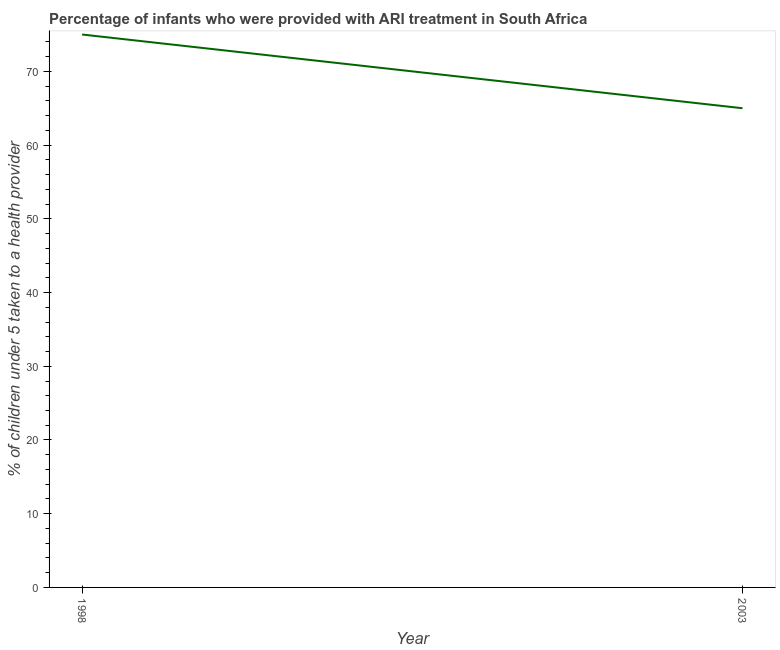What is the percentage of children who were provided with ari treatment in 1998?
Your answer should be compact. 75. Across all years, what is the maximum percentage of children who were provided with ari treatment?
Ensure brevity in your answer.  75. Across all years, what is the minimum percentage of children who were provided with ari treatment?
Give a very brief answer. 65. In which year was the percentage of children who were provided with ari treatment maximum?
Provide a succinct answer. 1998. What is the sum of the percentage of children who were provided with ari treatment?
Ensure brevity in your answer.  140. What is the difference between the percentage of children who were provided with ari treatment in 1998 and 2003?
Give a very brief answer. 10. In how many years, is the percentage of children who were provided with ari treatment greater than 2 %?
Your response must be concise. 2. Do a majority of the years between 1998 and 2003 (inclusive) have percentage of children who were provided with ari treatment greater than 28 %?
Make the answer very short. Yes. What is the ratio of the percentage of children who were provided with ari treatment in 1998 to that in 2003?
Ensure brevity in your answer.  1.15. How many years are there in the graph?
Give a very brief answer. 2. Are the values on the major ticks of Y-axis written in scientific E-notation?
Keep it short and to the point. No. Does the graph contain any zero values?
Offer a terse response. No. Does the graph contain grids?
Give a very brief answer. No. What is the title of the graph?
Your response must be concise. Percentage of infants who were provided with ARI treatment in South Africa. What is the label or title of the X-axis?
Offer a terse response. Year. What is the label or title of the Y-axis?
Your answer should be very brief. % of children under 5 taken to a health provider. What is the % of children under 5 taken to a health provider of 1998?
Your response must be concise. 75. What is the ratio of the % of children under 5 taken to a health provider in 1998 to that in 2003?
Give a very brief answer. 1.15. 